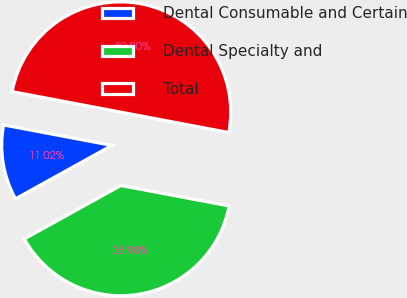Convert chart to OTSL. <chart><loc_0><loc_0><loc_500><loc_500><pie_chart><fcel>Dental Consumable and Certain<fcel>Dental Specialty and<fcel>Total<nl><fcel>11.02%<fcel>38.98%<fcel>50.0%<nl></chart> 